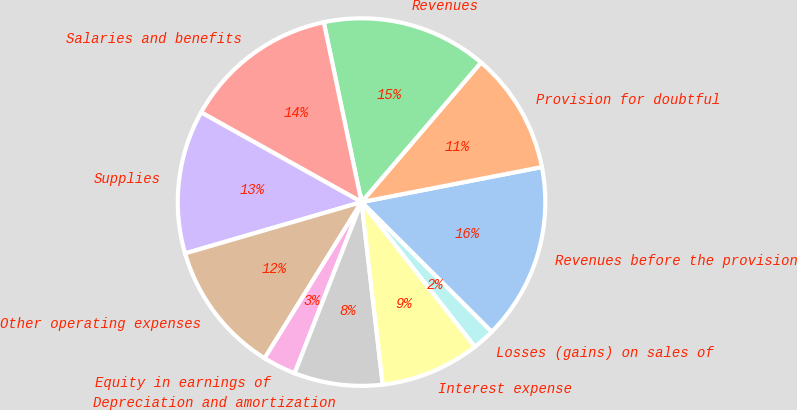Convert chart. <chart><loc_0><loc_0><loc_500><loc_500><pie_chart><fcel>Revenues before the provision<fcel>Provision for doubtful<fcel>Revenues<fcel>Salaries and benefits<fcel>Supplies<fcel>Other operating expenses<fcel>Equity in earnings of<fcel>Depreciation and amortization<fcel>Interest expense<fcel>Losses (gains) on sales of<nl><fcel>15.53%<fcel>10.68%<fcel>14.56%<fcel>13.59%<fcel>12.62%<fcel>11.65%<fcel>2.91%<fcel>7.77%<fcel>8.74%<fcel>1.94%<nl></chart> 